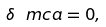<formula> <loc_0><loc_0><loc_500><loc_500>\delta \ m c a = 0 ,</formula> 